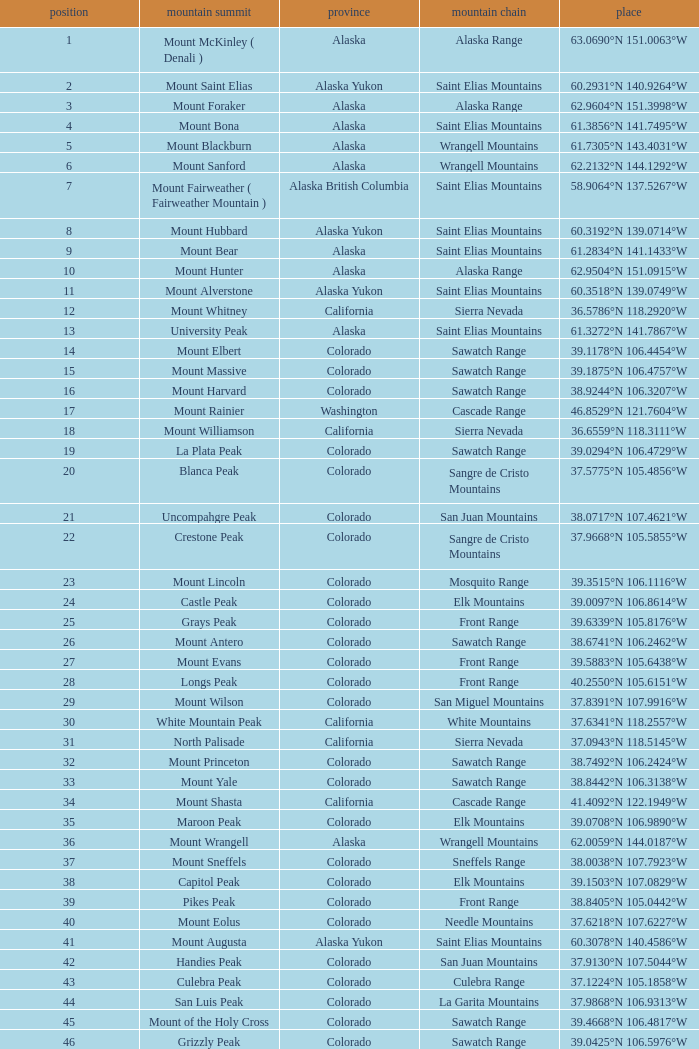What is the mountain peak when the location is 37.5775°n 105.4856°w? Blanca Peak. 